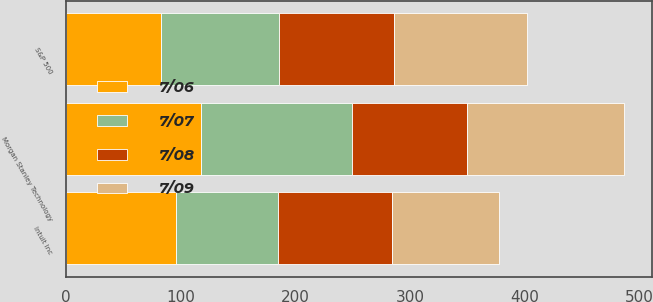<chart> <loc_0><loc_0><loc_500><loc_500><stacked_bar_chart><ecel><fcel>Intuit Inc<fcel>S&P 500<fcel>Morgan Stanley Technology<nl><fcel>7/08<fcel>100<fcel>100<fcel>100<nl><fcel>7/09<fcel>92.78<fcel>116.13<fcel>137.24<nl><fcel>7/07<fcel>88.53<fcel>103.25<fcel>131.98<nl><fcel>7/06<fcel>96.21<fcel>82.64<fcel>117.74<nl></chart> 